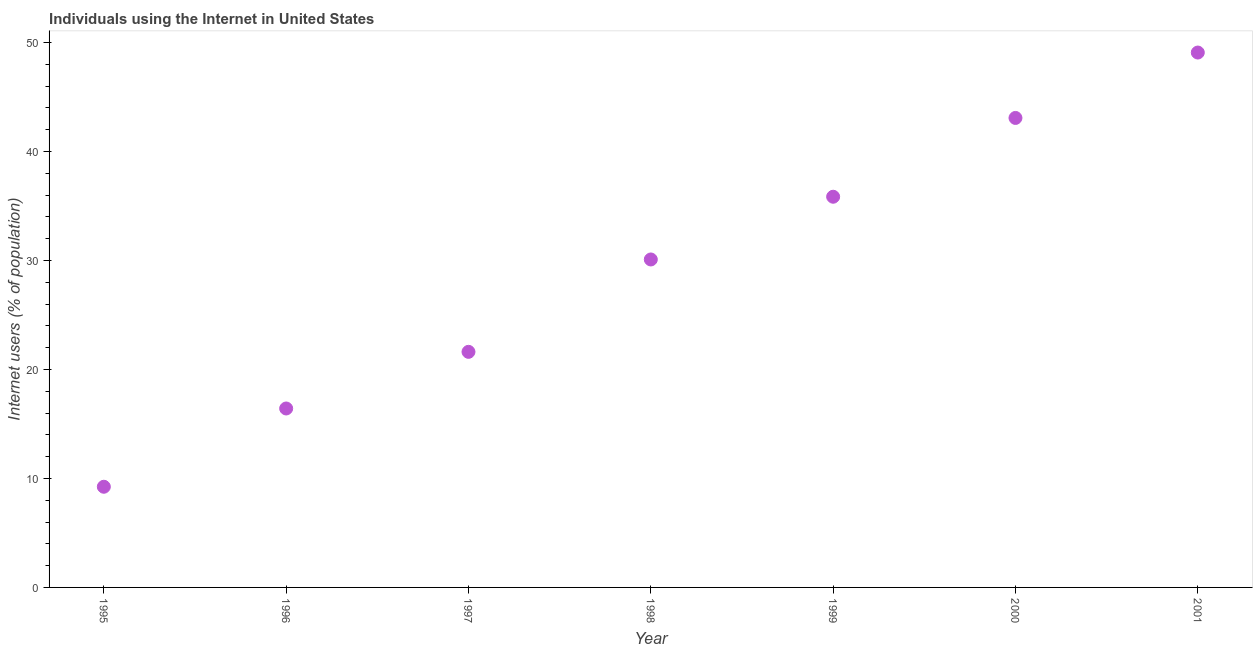What is the number of internet users in 1995?
Keep it short and to the point. 9.24. Across all years, what is the maximum number of internet users?
Keep it short and to the point. 49.08. Across all years, what is the minimum number of internet users?
Provide a succinct answer. 9.24. In which year was the number of internet users minimum?
Ensure brevity in your answer.  1995. What is the sum of the number of internet users?
Provide a succinct answer. 205.37. What is the difference between the number of internet users in 1996 and 1997?
Offer a terse response. -5.2. What is the average number of internet users per year?
Your response must be concise. 29.34. What is the median number of internet users?
Make the answer very short. 30.09. Do a majority of the years between 1999 and 1998 (inclusive) have number of internet users greater than 12 %?
Keep it short and to the point. No. What is the ratio of the number of internet users in 1998 to that in 1999?
Offer a terse response. 0.84. Is the difference between the number of internet users in 1996 and 1997 greater than the difference between any two years?
Offer a terse response. No. What is the difference between the highest and the second highest number of internet users?
Offer a very short reply. 6. Is the sum of the number of internet users in 1998 and 1999 greater than the maximum number of internet users across all years?
Offer a very short reply. Yes. What is the difference between the highest and the lowest number of internet users?
Your response must be concise. 39.84. Does the number of internet users monotonically increase over the years?
Provide a succinct answer. Yes. How many years are there in the graph?
Your answer should be compact. 7. Does the graph contain grids?
Provide a short and direct response. No. What is the title of the graph?
Keep it short and to the point. Individuals using the Internet in United States. What is the label or title of the Y-axis?
Offer a terse response. Internet users (% of population). What is the Internet users (% of population) in 1995?
Offer a very short reply. 9.24. What is the Internet users (% of population) in 1996?
Offer a very short reply. 16.42. What is the Internet users (% of population) in 1997?
Offer a very short reply. 21.62. What is the Internet users (% of population) in 1998?
Your response must be concise. 30.09. What is the Internet users (% of population) in 1999?
Your answer should be compact. 35.85. What is the Internet users (% of population) in 2000?
Your response must be concise. 43.08. What is the Internet users (% of population) in 2001?
Make the answer very short. 49.08. What is the difference between the Internet users (% of population) in 1995 and 1996?
Ensure brevity in your answer.  -7.18. What is the difference between the Internet users (% of population) in 1995 and 1997?
Keep it short and to the point. -12.38. What is the difference between the Internet users (% of population) in 1995 and 1998?
Offer a very short reply. -20.86. What is the difference between the Internet users (% of population) in 1995 and 1999?
Keep it short and to the point. -26.61. What is the difference between the Internet users (% of population) in 1995 and 2000?
Provide a short and direct response. -33.84. What is the difference between the Internet users (% of population) in 1995 and 2001?
Your response must be concise. -39.84. What is the difference between the Internet users (% of population) in 1996 and 1997?
Make the answer very short. -5.2. What is the difference between the Internet users (% of population) in 1996 and 1998?
Keep it short and to the point. -13.67. What is the difference between the Internet users (% of population) in 1996 and 1999?
Make the answer very short. -19.43. What is the difference between the Internet users (% of population) in 1996 and 2000?
Your answer should be compact. -26.66. What is the difference between the Internet users (% of population) in 1996 and 2001?
Give a very brief answer. -32.66. What is the difference between the Internet users (% of population) in 1997 and 1998?
Your answer should be compact. -8.48. What is the difference between the Internet users (% of population) in 1997 and 1999?
Keep it short and to the point. -14.23. What is the difference between the Internet users (% of population) in 1997 and 2000?
Ensure brevity in your answer.  -21.46. What is the difference between the Internet users (% of population) in 1997 and 2001?
Make the answer very short. -27.46. What is the difference between the Internet users (% of population) in 1998 and 1999?
Your answer should be compact. -5.76. What is the difference between the Internet users (% of population) in 1998 and 2000?
Provide a succinct answer. -12.99. What is the difference between the Internet users (% of population) in 1998 and 2001?
Give a very brief answer. -18.99. What is the difference between the Internet users (% of population) in 1999 and 2000?
Ensure brevity in your answer.  -7.23. What is the difference between the Internet users (% of population) in 1999 and 2001?
Your response must be concise. -13.23. What is the difference between the Internet users (% of population) in 2000 and 2001?
Make the answer very short. -6. What is the ratio of the Internet users (% of population) in 1995 to that in 1996?
Your answer should be compact. 0.56. What is the ratio of the Internet users (% of population) in 1995 to that in 1997?
Give a very brief answer. 0.43. What is the ratio of the Internet users (% of population) in 1995 to that in 1998?
Offer a terse response. 0.31. What is the ratio of the Internet users (% of population) in 1995 to that in 1999?
Make the answer very short. 0.26. What is the ratio of the Internet users (% of population) in 1995 to that in 2000?
Provide a succinct answer. 0.21. What is the ratio of the Internet users (% of population) in 1995 to that in 2001?
Provide a succinct answer. 0.19. What is the ratio of the Internet users (% of population) in 1996 to that in 1997?
Ensure brevity in your answer.  0.76. What is the ratio of the Internet users (% of population) in 1996 to that in 1998?
Your answer should be compact. 0.55. What is the ratio of the Internet users (% of population) in 1996 to that in 1999?
Keep it short and to the point. 0.46. What is the ratio of the Internet users (% of population) in 1996 to that in 2000?
Your answer should be compact. 0.38. What is the ratio of the Internet users (% of population) in 1996 to that in 2001?
Keep it short and to the point. 0.34. What is the ratio of the Internet users (% of population) in 1997 to that in 1998?
Provide a short and direct response. 0.72. What is the ratio of the Internet users (% of population) in 1997 to that in 1999?
Provide a succinct answer. 0.6. What is the ratio of the Internet users (% of population) in 1997 to that in 2000?
Make the answer very short. 0.5. What is the ratio of the Internet users (% of population) in 1997 to that in 2001?
Make the answer very short. 0.44. What is the ratio of the Internet users (% of population) in 1998 to that in 1999?
Offer a very short reply. 0.84. What is the ratio of the Internet users (% of population) in 1998 to that in 2000?
Provide a succinct answer. 0.7. What is the ratio of the Internet users (% of population) in 1998 to that in 2001?
Your response must be concise. 0.61. What is the ratio of the Internet users (% of population) in 1999 to that in 2000?
Your answer should be compact. 0.83. What is the ratio of the Internet users (% of population) in 1999 to that in 2001?
Keep it short and to the point. 0.73. What is the ratio of the Internet users (% of population) in 2000 to that in 2001?
Offer a very short reply. 0.88. 